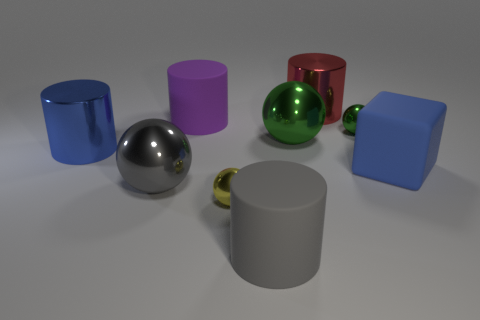Subtract all green spheres. How many were subtracted if there are1green spheres left? 1 Subtract 1 balls. How many balls are left? 3 Subtract all blocks. How many objects are left? 8 Subtract all tiny green balls. Subtract all red metallic cylinders. How many objects are left? 7 Add 9 big gray balls. How many big gray balls are left? 10 Add 7 tiny shiny objects. How many tiny shiny objects exist? 9 Subtract 1 red cylinders. How many objects are left? 8 